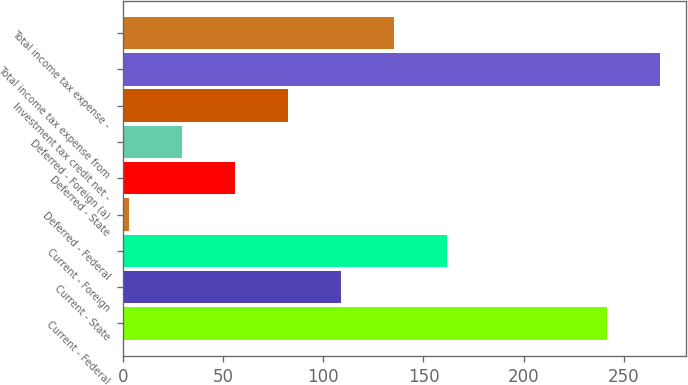Convert chart. <chart><loc_0><loc_0><loc_500><loc_500><bar_chart><fcel>Current - Federal<fcel>Current - State<fcel>Current - Foreign<fcel>Deferred - Federal<fcel>Deferred - State<fcel>Deferred - Foreign (a)<fcel>Investment tax credit net -<fcel>Total income tax expense from<fcel>Total income tax expense -<nl><fcel>241.5<fcel>109<fcel>162<fcel>3<fcel>56<fcel>29.5<fcel>82.5<fcel>268<fcel>135.5<nl></chart> 